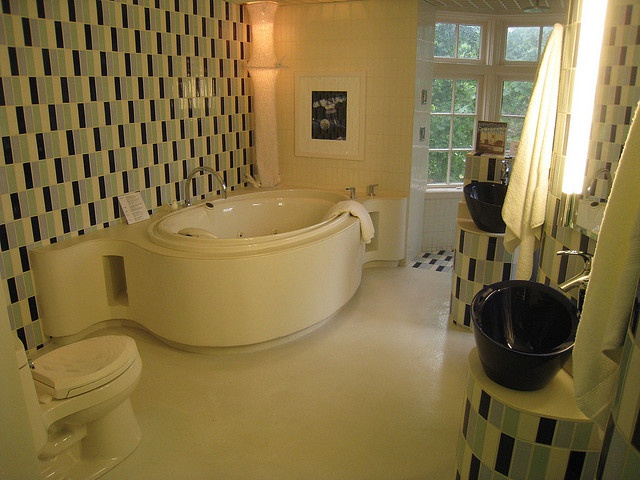Describe the objects in this image and their specific colors. I can see toilet in olive tones, sink in olive, black, darkgreen, and gray tones, and sink in olive, black, and gray tones in this image. 